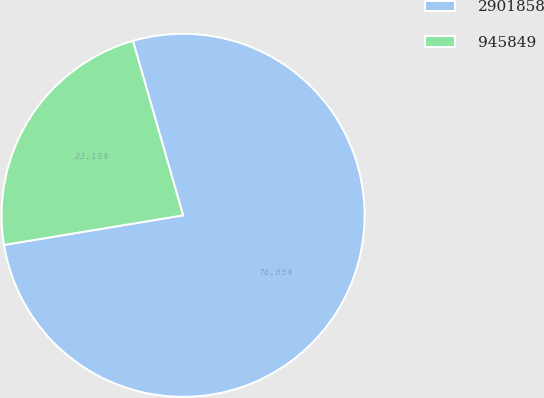Convert chart. <chart><loc_0><loc_0><loc_500><loc_500><pie_chart><fcel>2901858<fcel>945849<nl><fcel>76.85%<fcel>23.15%<nl></chart> 